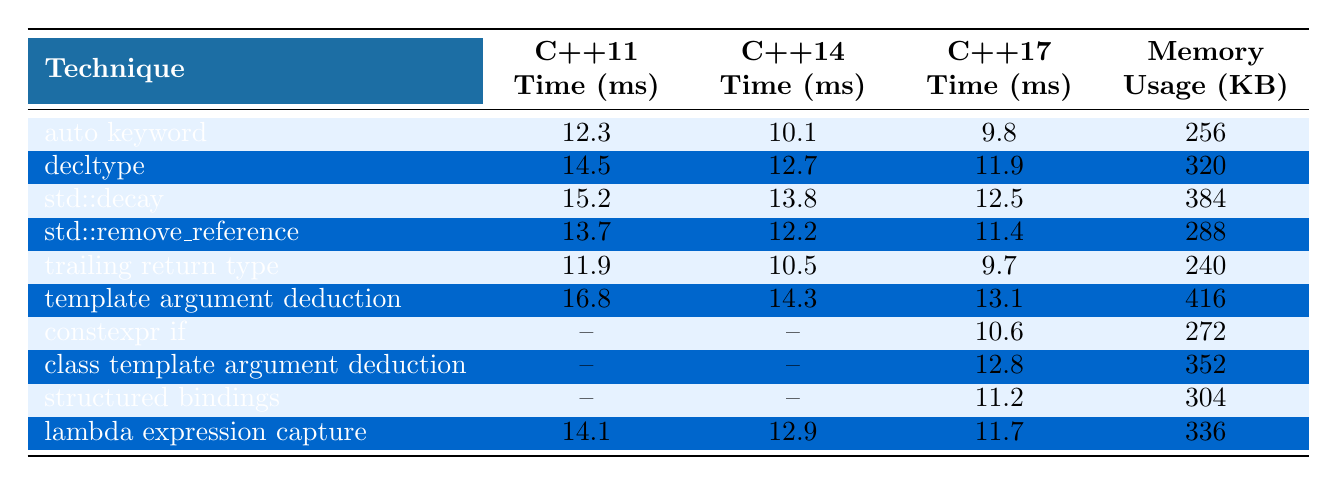What is the fastest time recorded for type deduction in C++17? The fastest time for C++17 is recorded for the "auto keyword" technique, which has a time of 9.8 ms.
Answer: 9.8 ms Which technique has the highest memory usage? The technique with the highest memory usage is "template argument deduction," which uses 416 KB.
Answer: 416 KB What is the average time for "decltype" across all versions? The times for "decltype" are 14.5 ms in C++11, 12.7 ms in C++14, and 11.9 ms in C++17. Summing these gives 14.5 + 12.7 + 11.9 = 39.1 ms. Dividing by 3 gives an average of 39.1 / 3 = 13.03 ms.
Answer: 13.03 ms Is there a technique that shows decreasing time across all C++ versions from C++11 to C++17? Yes, the "auto keyword," "trailing return type," and "decltype" techniques show a decrease in time across C++11, C++14, and C++17.
Answer: Yes Which C++ version had the most techniques listed with recorded times? The C++11 version listed the most techniques with recorded times, as 7 techniques had values provided.
Answer: C++11 What is the difference in time between "template argument deduction" in C++11 and C++17? "Template argument deduction" takes 16.8 ms in C++11 and 13.1 ms in C++17. The difference is 16.8 - 13.1 = 3.7 ms.
Answer: 3.7 ms Is there a technique that has a lower time in C++14 compared to C++11? Yes, the "auto keyword" has a lower time in C++14 (10.1 ms) compared to C++11 (12.3 ms).
Answer: Yes Which technique shows the most significant improvement in time from C++14 to C++17? The "template argument deduction" shows the most significant improvement, decreasing from 14.3 ms in C++14 to 13.1 ms in C++17, a difference of 1.2 ms.
Answer: 1.2 ms What is the median memory usage of the techniques listed? Sorting the memory usage values: 240, 256, 288, 304, 320, 336, 352, 384, 416 gives us 320 as the median (the average of the two middle values 320 and 304).
Answer: 320 KB 